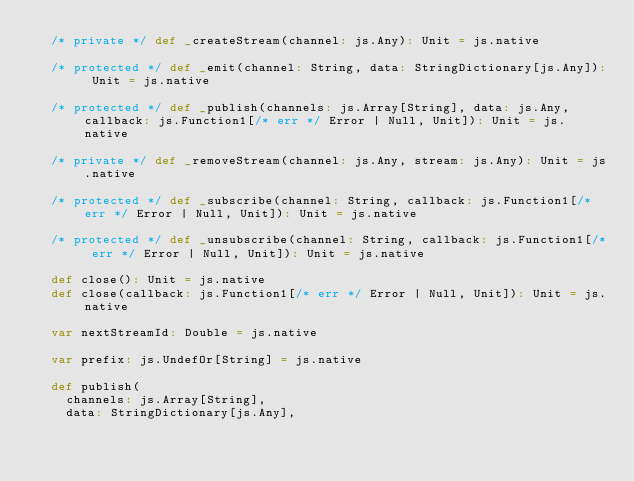Convert code to text. <code><loc_0><loc_0><loc_500><loc_500><_Scala_>  /* private */ def _createStream(channel: js.Any): Unit = js.native
  
  /* protected */ def _emit(channel: String, data: StringDictionary[js.Any]): Unit = js.native
  
  /* protected */ def _publish(channels: js.Array[String], data: js.Any, callback: js.Function1[/* err */ Error | Null, Unit]): Unit = js.native
  
  /* private */ def _removeStream(channel: js.Any, stream: js.Any): Unit = js.native
  
  /* protected */ def _subscribe(channel: String, callback: js.Function1[/* err */ Error | Null, Unit]): Unit = js.native
  
  /* protected */ def _unsubscribe(channel: String, callback: js.Function1[/* err */ Error | Null, Unit]): Unit = js.native
  
  def close(): Unit = js.native
  def close(callback: js.Function1[/* err */ Error | Null, Unit]): Unit = js.native
  
  var nextStreamId: Double = js.native
  
  var prefix: js.UndefOr[String] = js.native
  
  def publish(
    channels: js.Array[String],
    data: StringDictionary[js.Any],</code> 